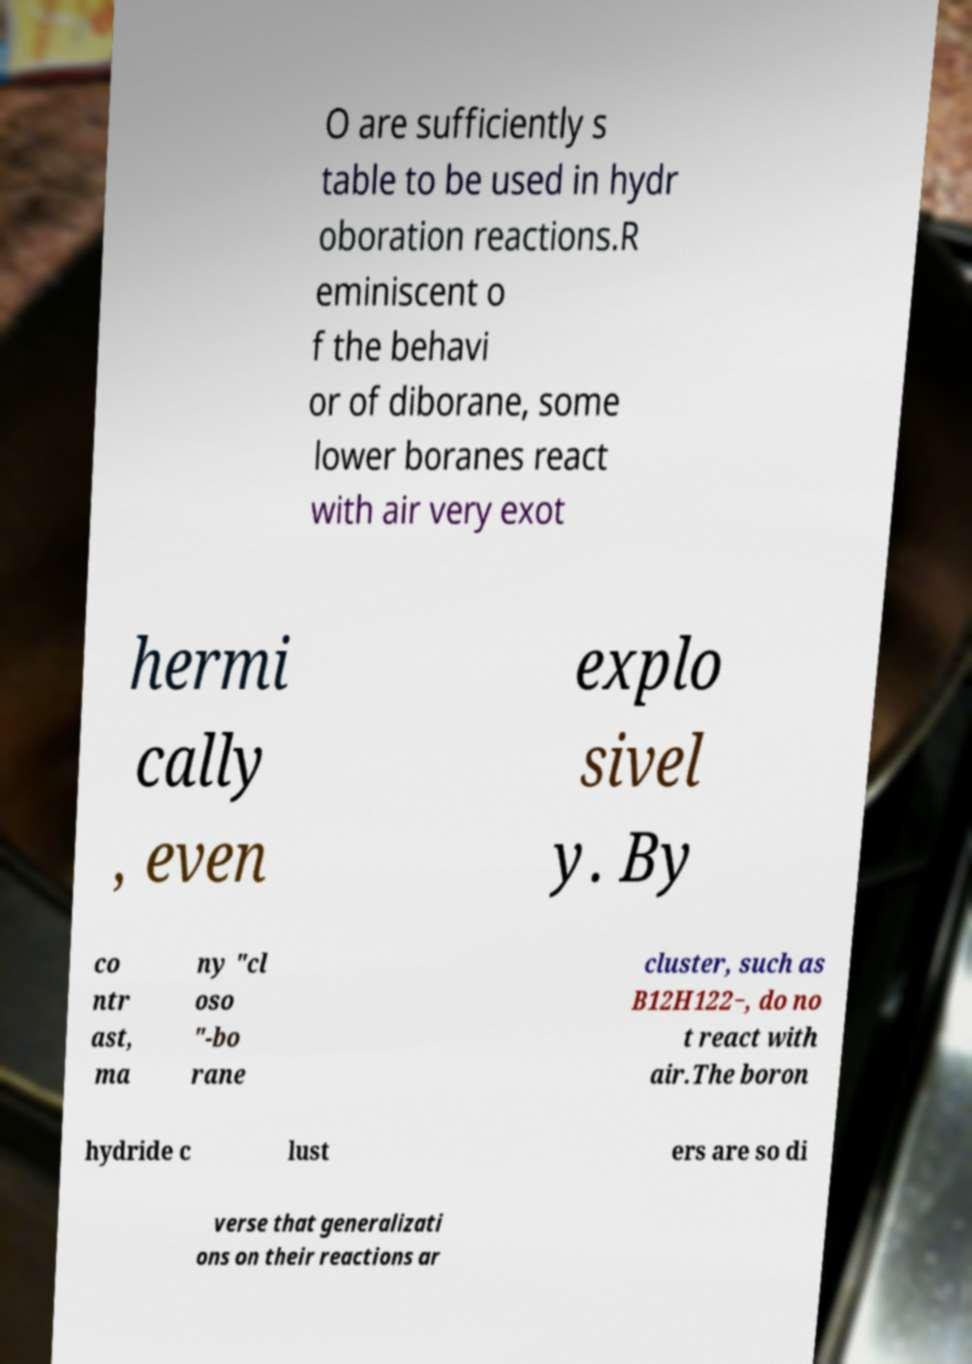Could you assist in decoding the text presented in this image and type it out clearly? O are sufficiently s table to be used in hydr oboration reactions.R eminiscent o f the behavi or of diborane, some lower boranes react with air very exot hermi cally , even explo sivel y. By co ntr ast, ma ny "cl oso "-bo rane cluster, such as B12H122−, do no t react with air.The boron hydride c lust ers are so di verse that generalizati ons on their reactions ar 